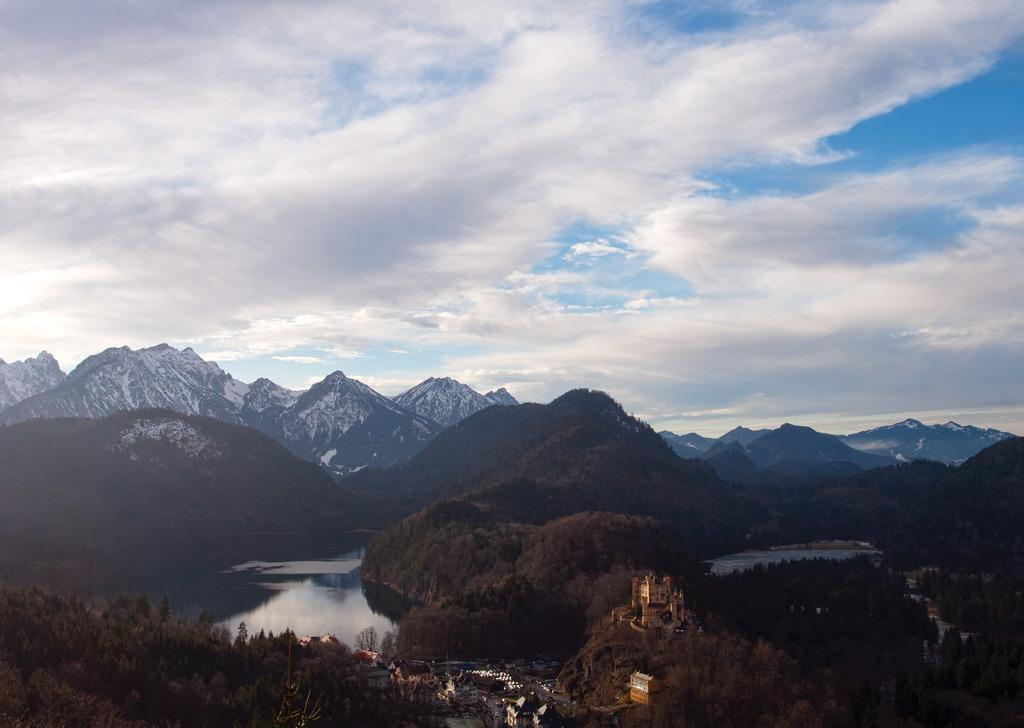What type of structures can be seen in the image? There are buildings in the image. What other natural elements are present in the image? There are plants, a water body, and a group of trees in the image. What can be seen in the distance in the image? Mountains are visible in the background of the image. What is visible in the sky in the image? The sky is visible in the background of the image, and it appears cloudy. What type of action are the sticks performing in the image? There are no sticks present in the image. What is the pot used for in the image? There is no pot present in the image. 